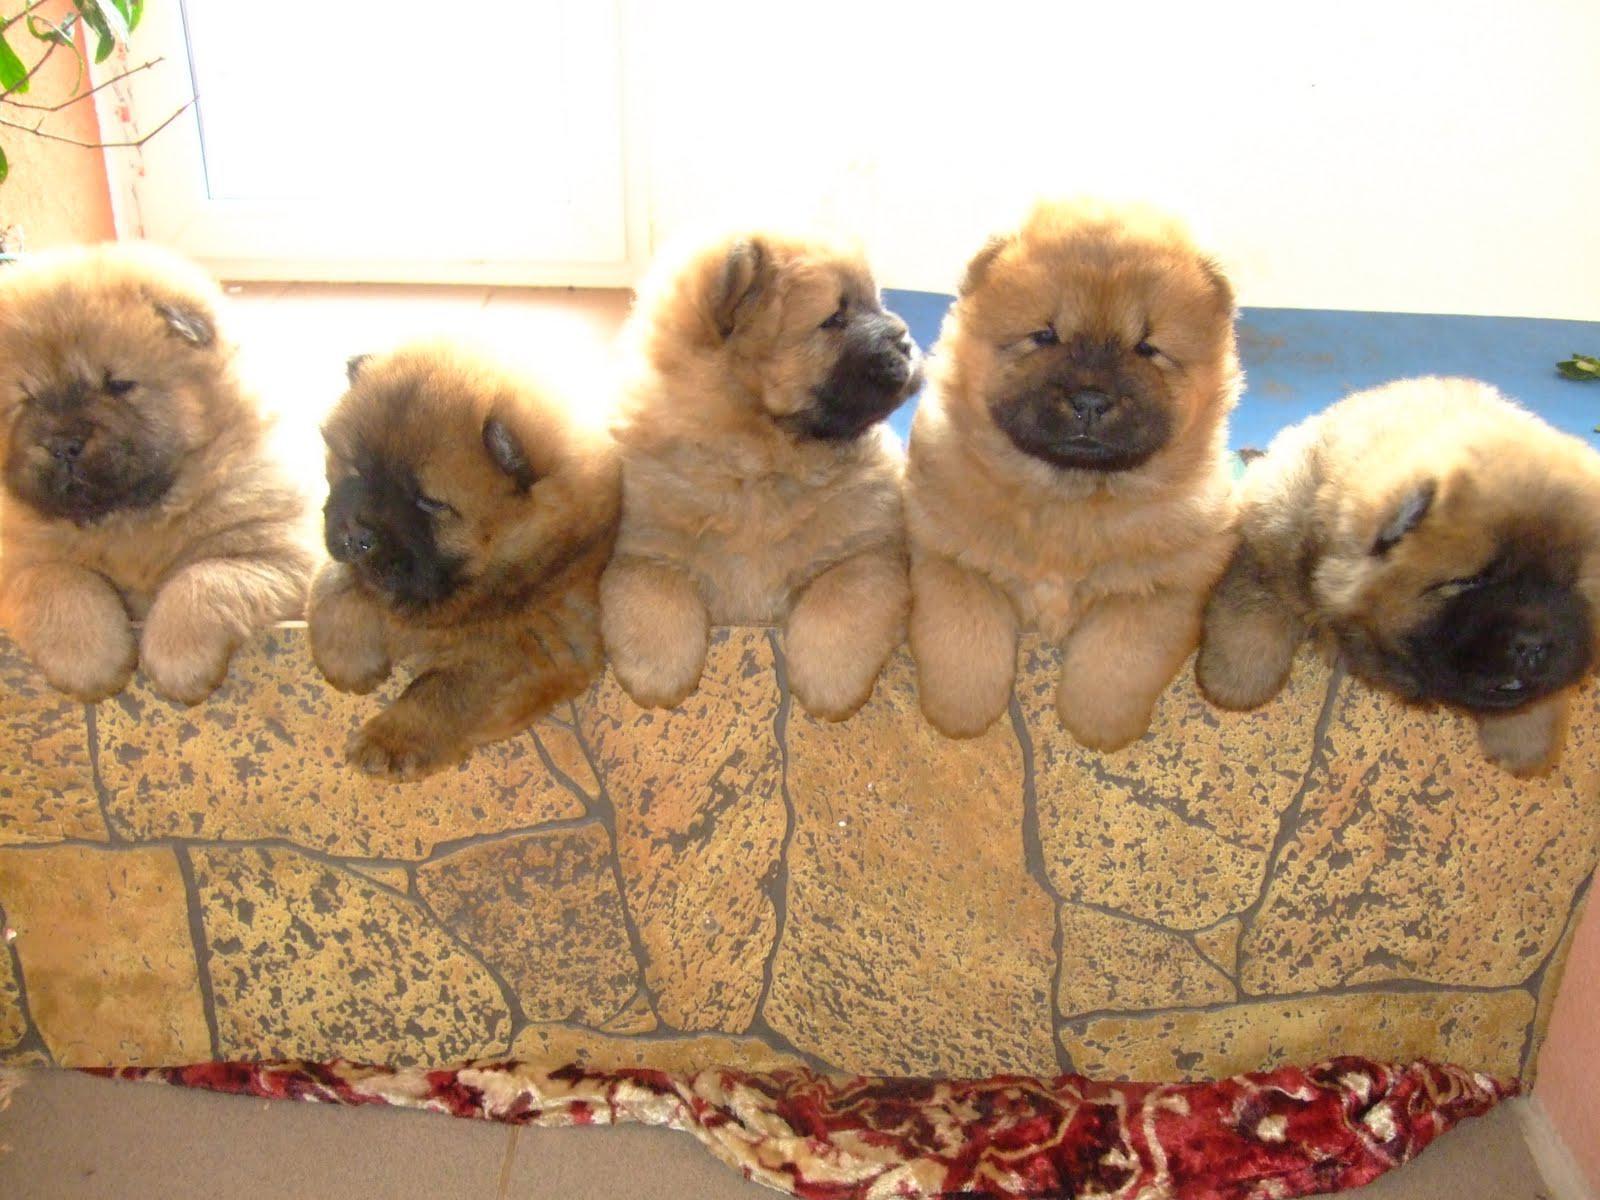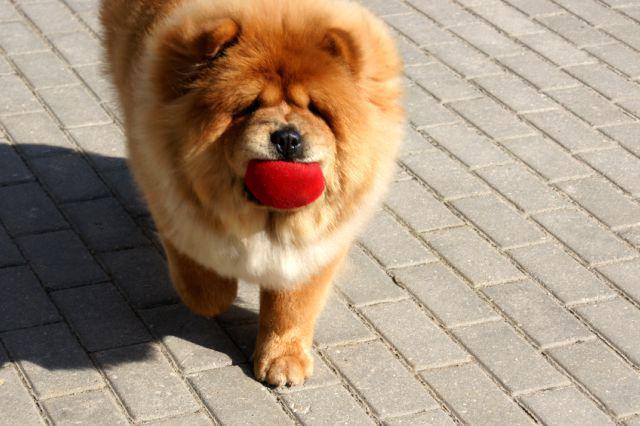The first image is the image on the left, the second image is the image on the right. Assess this claim about the two images: "There are no less than four dogs in one of the images.". Correct or not? Answer yes or no. Yes. The first image is the image on the left, the second image is the image on the right. For the images displayed, is the sentence "There are more than 4 dogs." factually correct? Answer yes or no. Yes. 